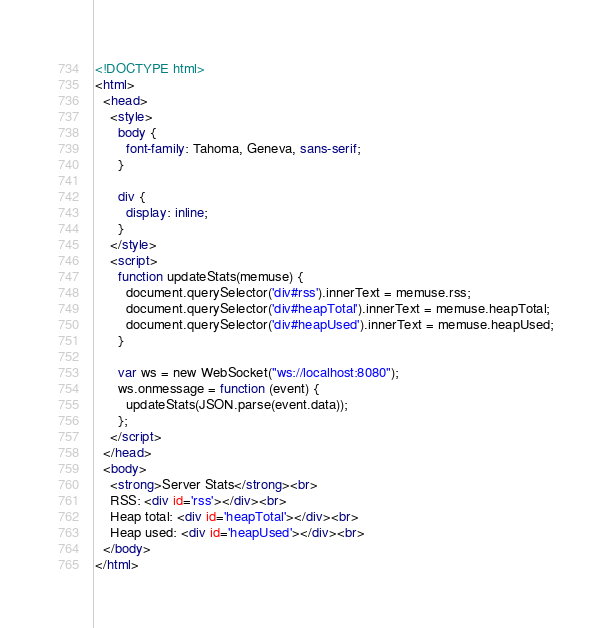Convert code to text. <code><loc_0><loc_0><loc_500><loc_500><_HTML_><!DOCTYPE html>
<html>
  <head>
    <style>
      body {
        font-family: Tahoma, Geneva, sans-serif;
      }

      div {
        display: inline;
      }
    </style>
    <script>
      function updateStats(memuse) {
        document.querySelector('div#rss').innerText = memuse.rss;
        document.querySelector('div#heapTotal').innerText = memuse.heapTotal;
        document.querySelector('div#heapUsed').innerText = memuse.heapUsed;
      }

      var ws = new WebSocket("ws://localhost:8080");
      ws.onmessage = function (event) {
        updateStats(JSON.parse(event.data));
      };
    </script>
  </head>
  <body>
    <strong>Server Stats</strong><br>
    RSS: <div id='rss'></div><br>
    Heap total: <div id='heapTotal'></div><br>
    Heap used: <div id='heapUsed'></div><br>
  </body>
</html>
</code> 